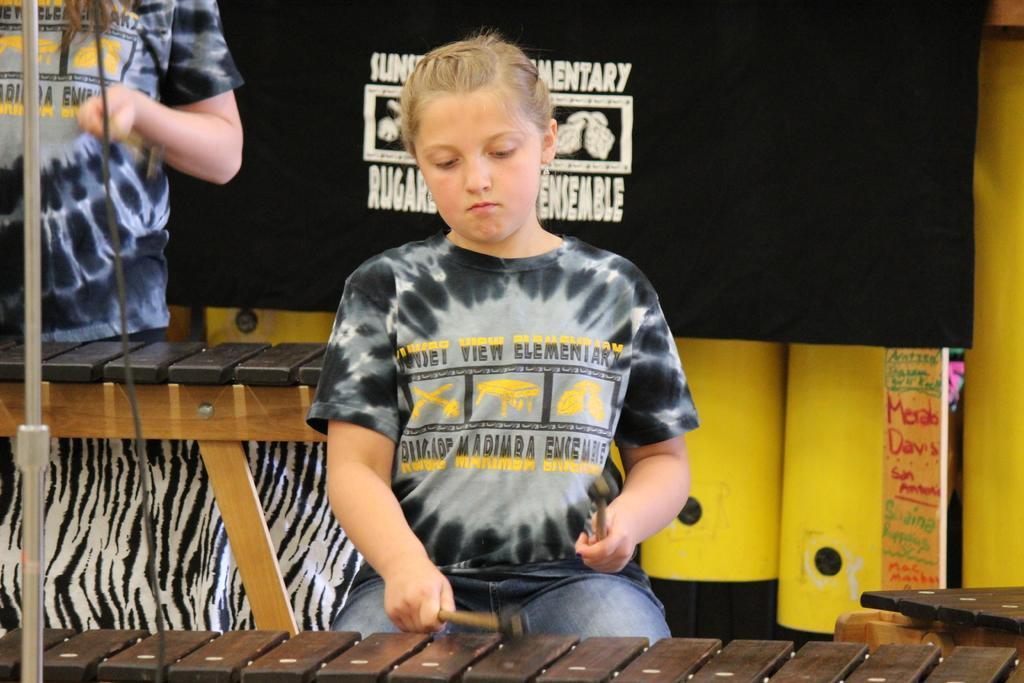Please provide a concise description of this image. In the foreground a girl is sitting on the chair in front of the table and holding an object in her hand. In the top left a person half visible who is standing and a rod visible. In the background, a poster and a yellow color background is visible. This image is taken inside a hall. 